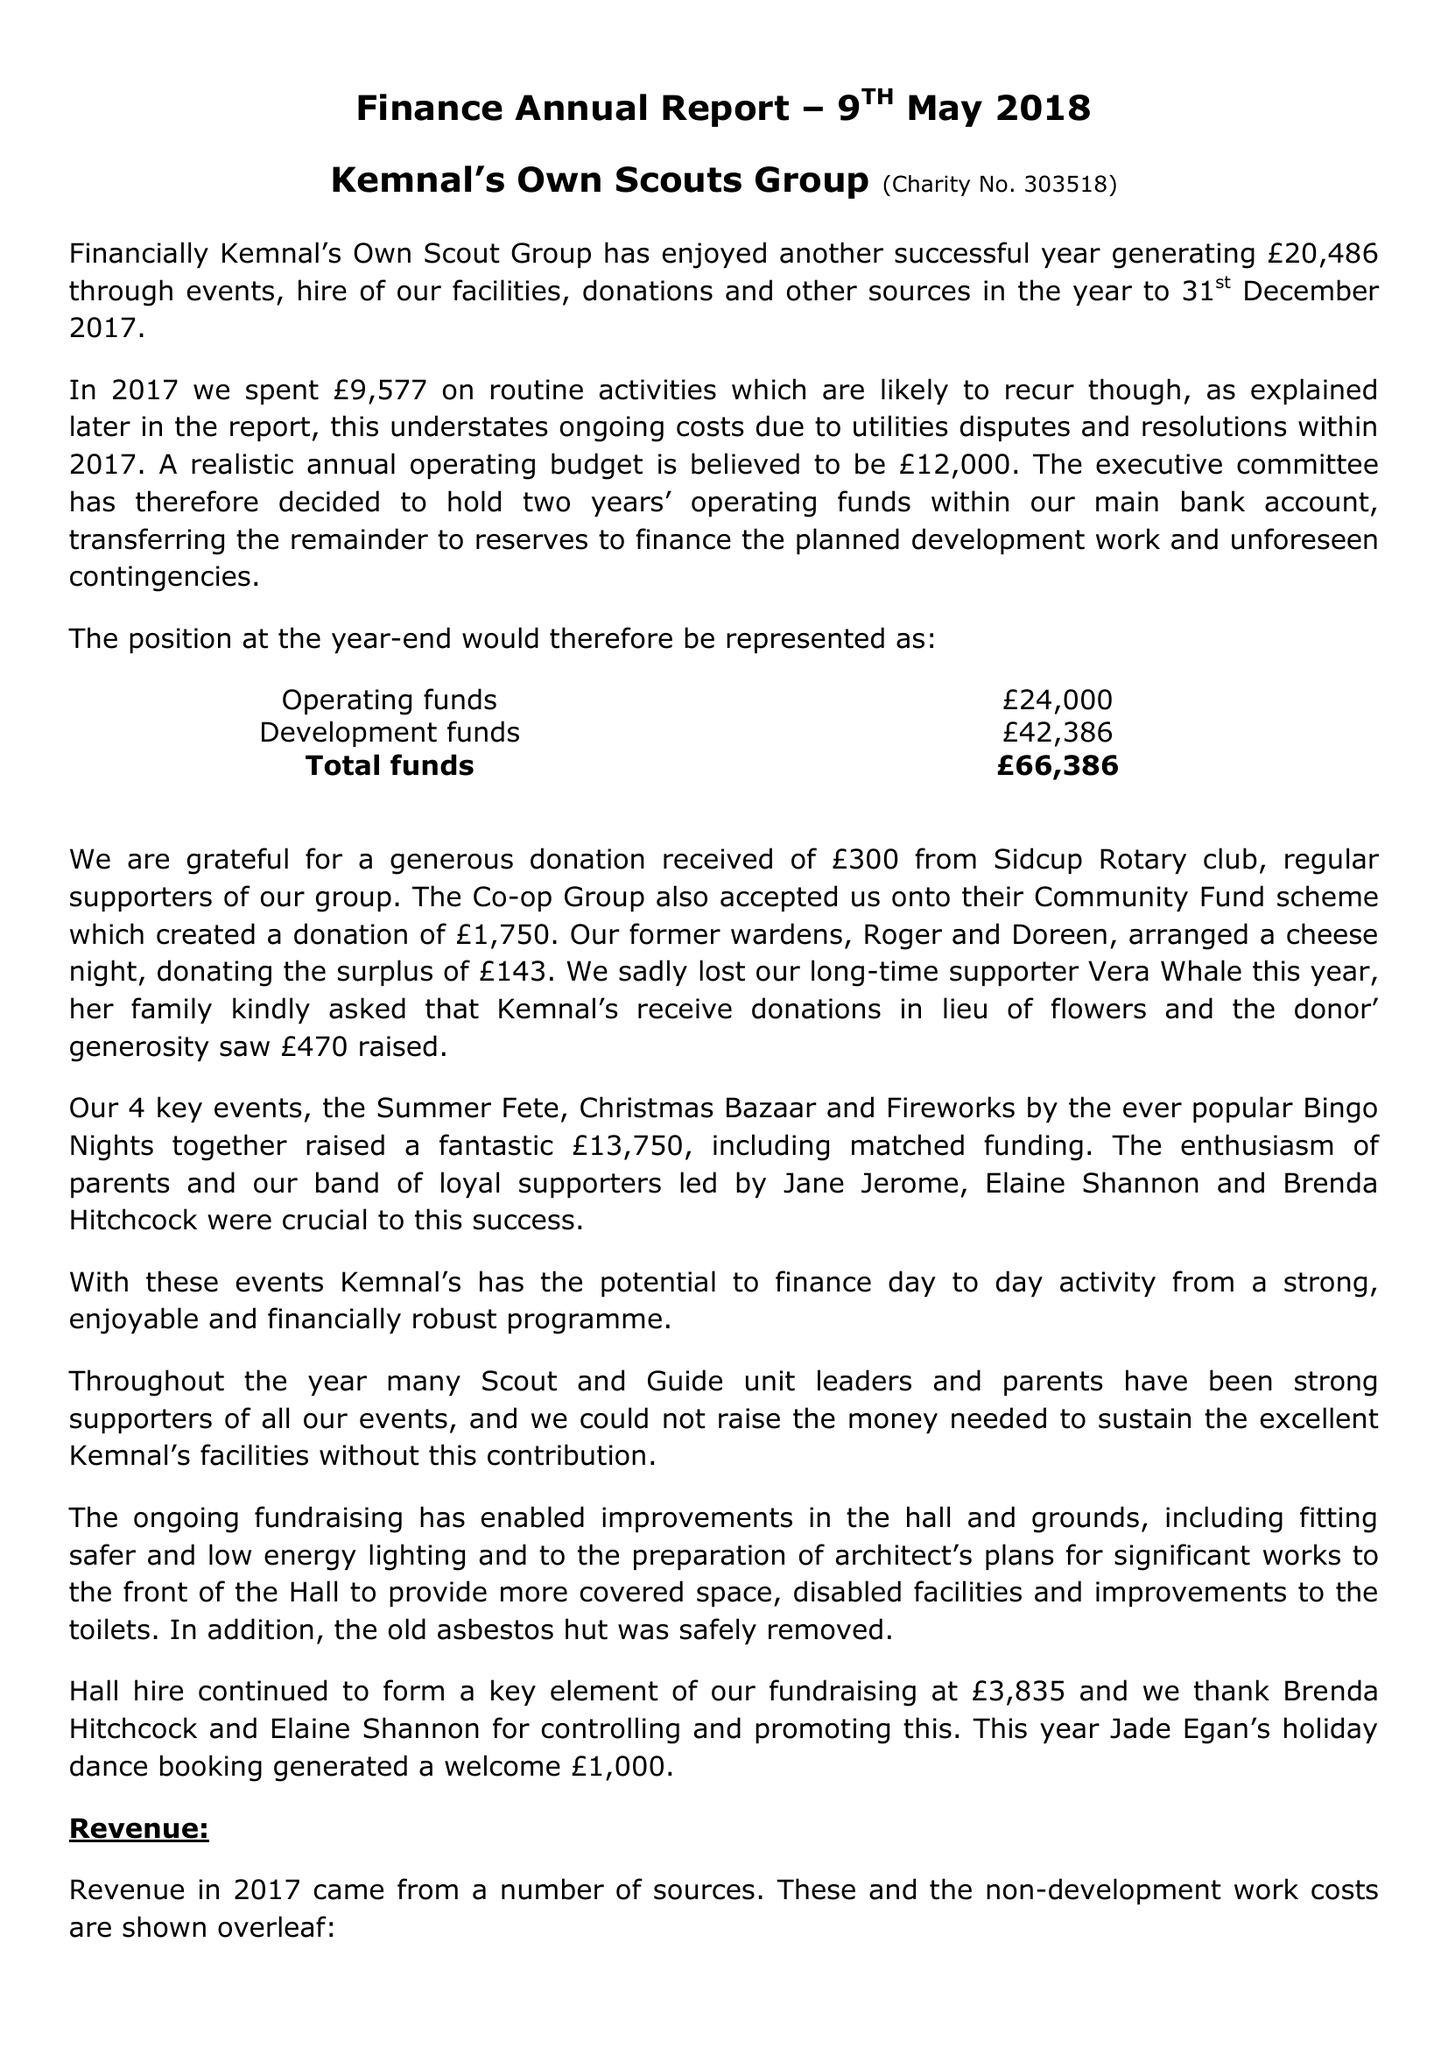What is the value for the spending_annually_in_british_pounds?
Answer the question using a single word or phrase. 9576.80 